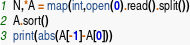<code> <loc_0><loc_0><loc_500><loc_500><_Python_>N,*A = map(int,open(0).read().split())
A.sort()
print(abs(A[-1]-A[0]))</code> 